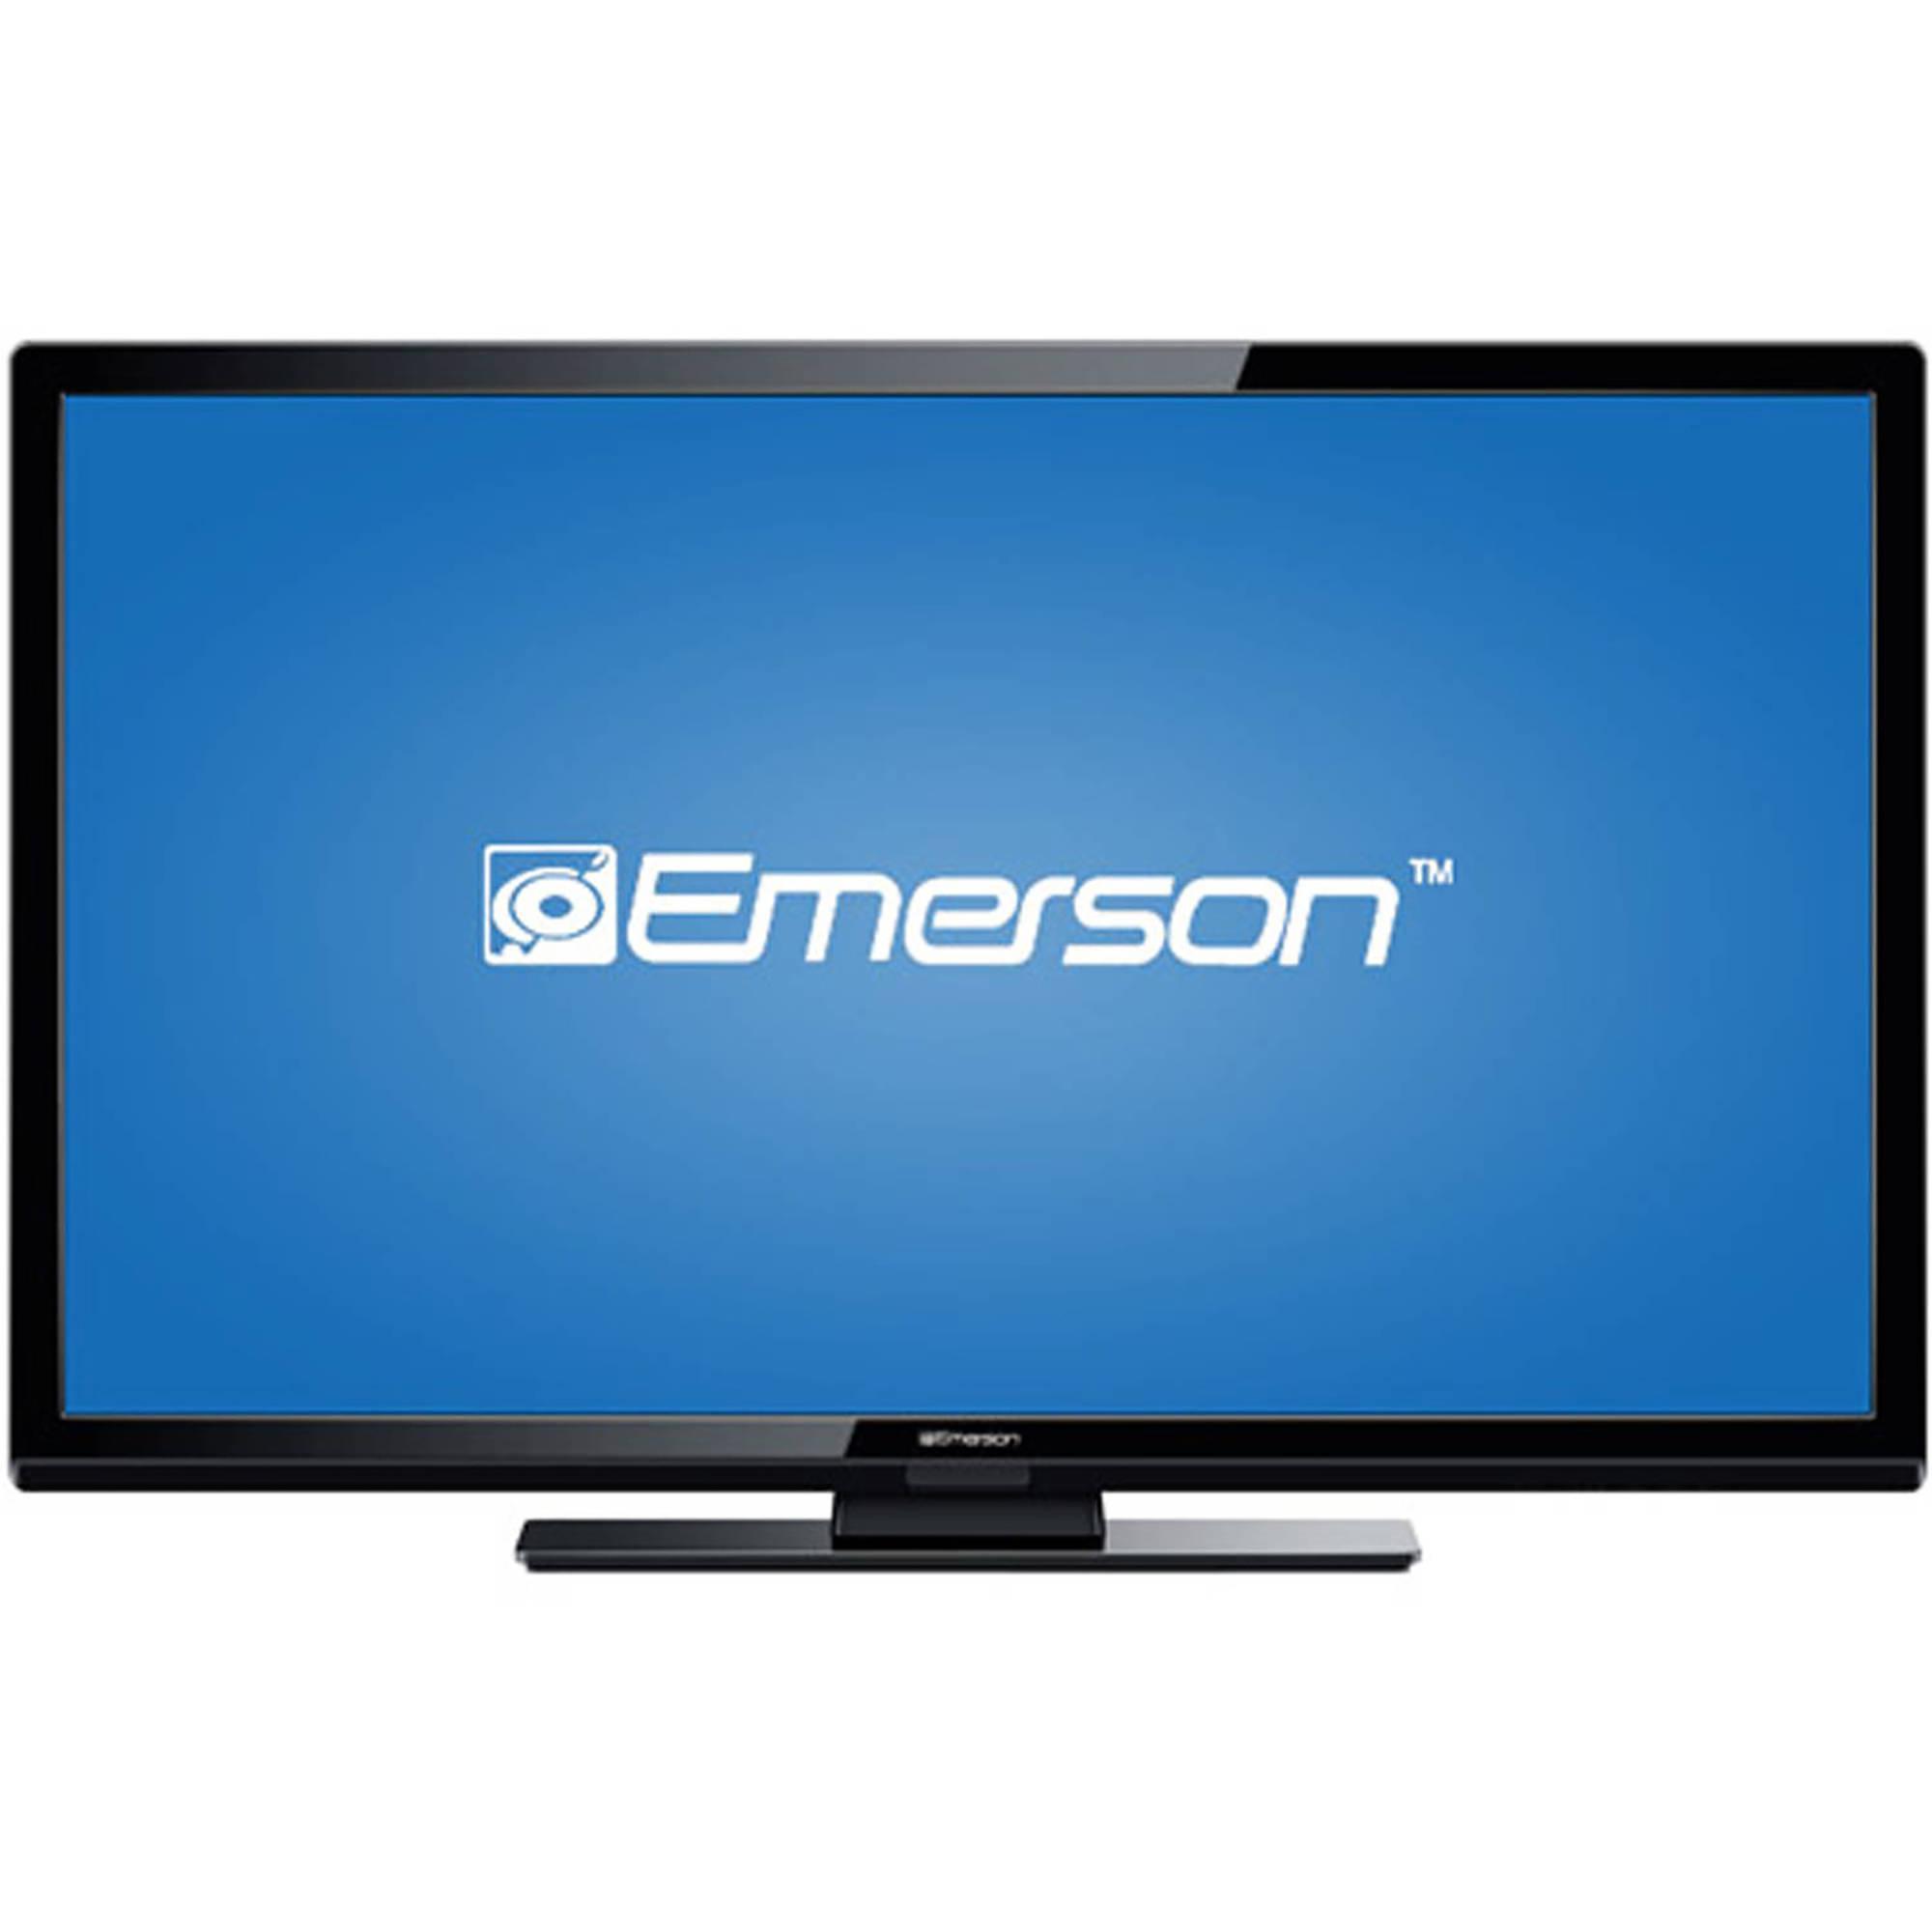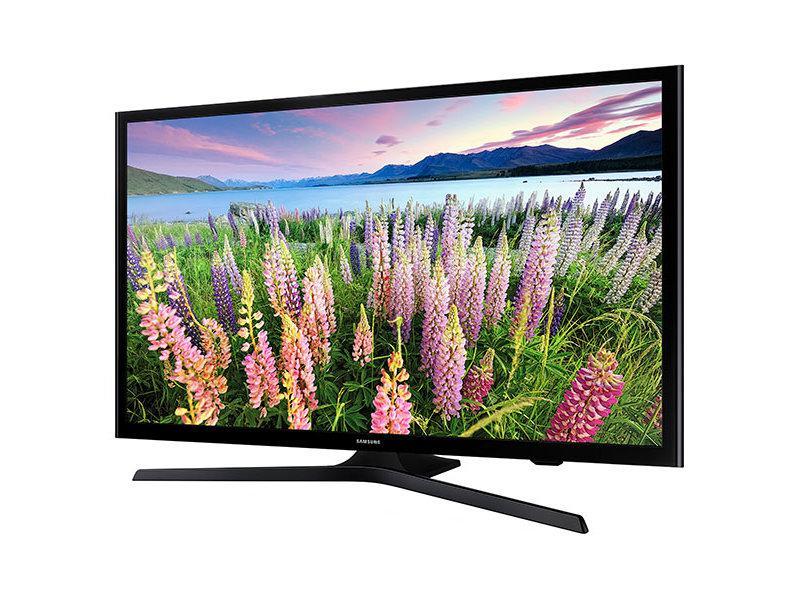The first image is the image on the left, the second image is the image on the right. Evaluate the accuracy of this statement regarding the images: "There are apps displayed on the television.". Is it true? Answer yes or no. No. The first image is the image on the left, the second image is the image on the right. Considering the images on both sides, is "At least one television has two legs." valid? Answer yes or no. No. 